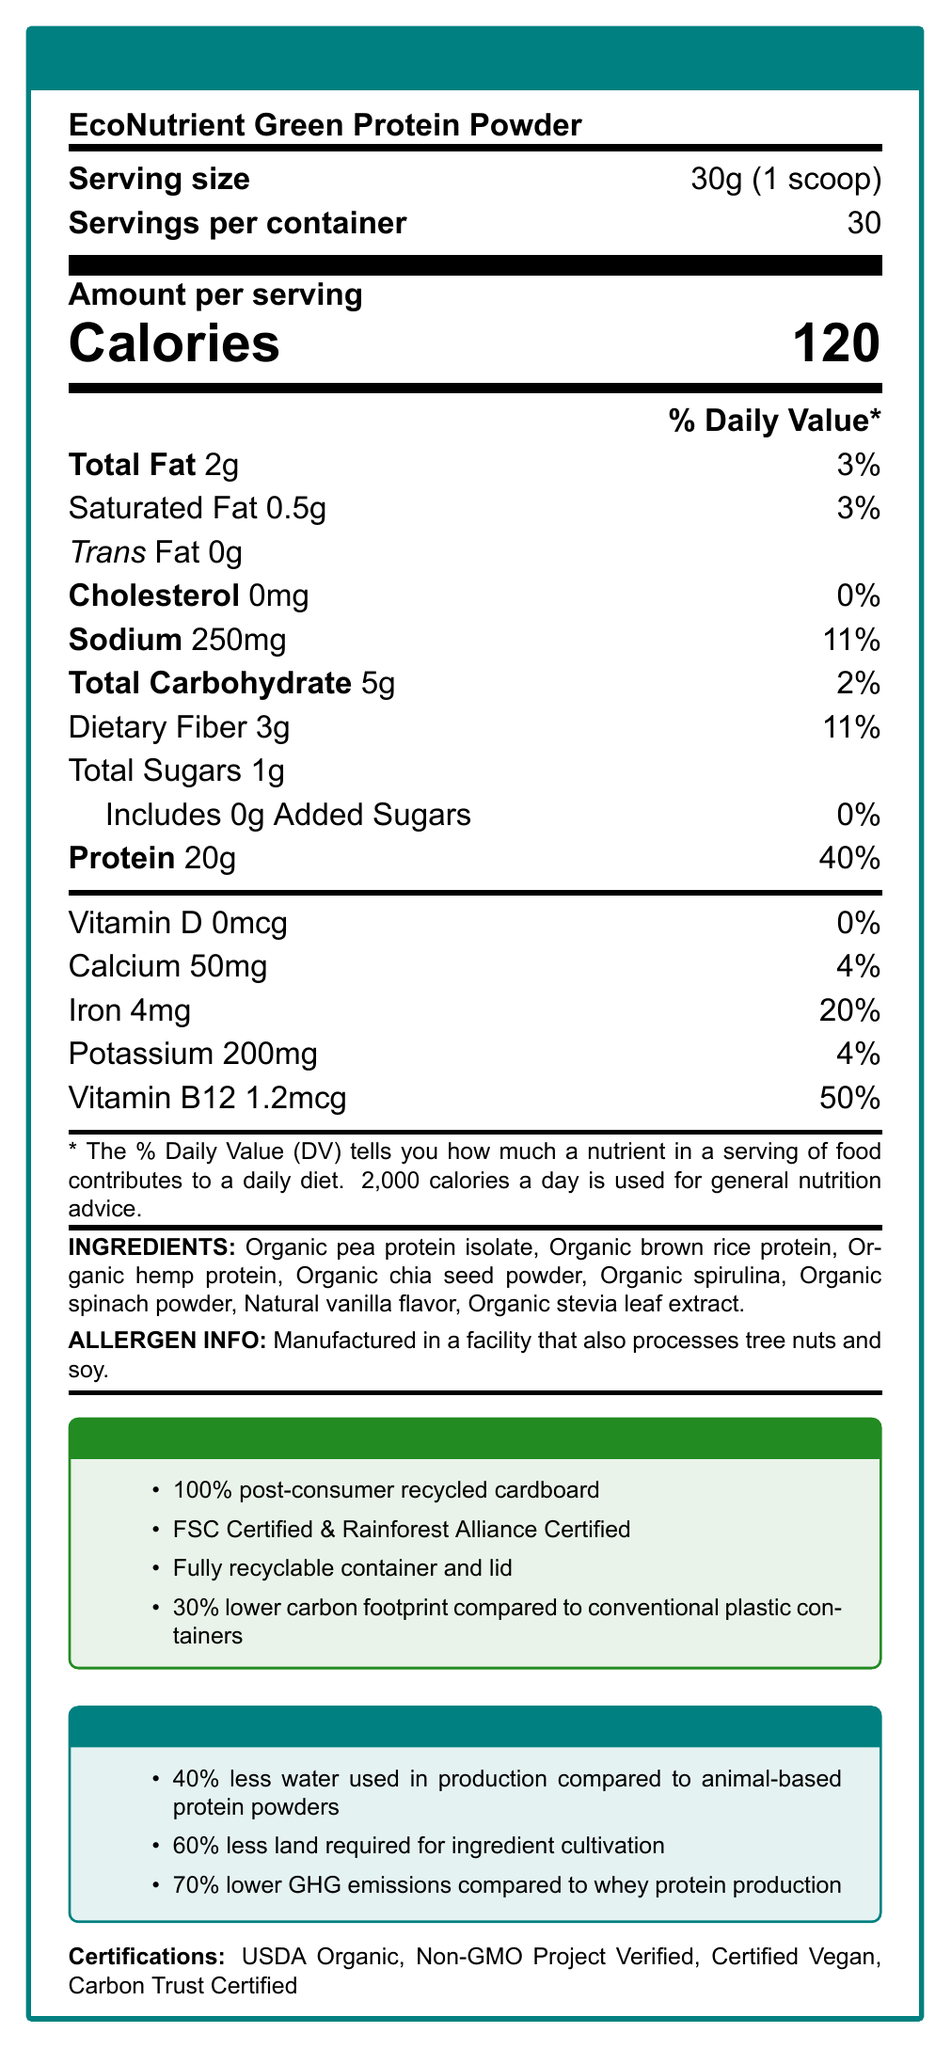what is the serving size? The document clearly states the serving size as 30g, which is equivalent to 1 scoop.
Answer: 30g (1 scoop) how many calories are there per serving? The document specifies that there are 120 calories per serving.
Answer: 120 what percentage of daily value for protein does one serving provide? According to the document, one serving of the protein powder provides 40% of the daily value for protein.
Answer: 40% are there any added sugars in this product? The document indicates that the product includes 0g of added sugars, contributing to 0% of the daily value.
Answer: No what are the main ingredients in this protein powder? The document lists these components as the main ingredients.
Answer: Organic pea protein isolate, Organic brown rice protein, Organic hemp protein, Organic chia seed powder, Organic spirulina, Organic spinach powder, Natural vanilla flavor, Organic stevia leaf extract which vitamins and minerals are included, and at what daily values? A. Vitamin D - 50%, Vitamin B12 - 20% B. Calcium - 4%, Iron - 20% C. Potassium - 50%, Iron - 4% D. Vitamin B12 - 50%, Potassium - 4% The document shows Vitamin B12 at 50% daily value and Potassium at 4% daily value.
Answer: D what material is used for the packaging of this product? A. Biodegradable plastic B. Recycled paper C. Recycled aluminum D. Post-consumer recycled cardboard The document states the packaging material is 100% post-consumer recycled cardboard.
Answer: D does the packaging have any certifications? The document mentions FSC Certified and Rainforest Alliance Certified for the packaging.
Answer: Yes is this product vegan? The document states that the product is vegan and cruelty-free.
Answer: Yes what is the total fat content per serving? The document indicates the total fat content per serving is 2g.
Answer: 2g how does the water usage for producing this product compare to animal-based protein powders? The environmental impact section of the document claims that the production of this product uses 40% less water than animal-based protein powders.
Answer: 40% less what certifications does this product have? The document lists these certifications under the certifications section.
Answer: USDA Organic, Non-GMO Project Verified, Certified Vegan, Carbon Trust Certified where is the pea protein sourced from? The document specifies that the pea protein in this product is sourced from Canada.
Answer: Canada summarize the main points of this nutrition facts label of the product. This summary includes the key points about the nutritional content, ingredient sourcing, eco-friendly packaging, certifications, and environmental impact of the product.
Answer: The nutrition facts label for EcoNutrient Green Protein Powder details its nutritional content per 30g serving, including 120 calories and 20g of protein. It is made from organic, non-GMO ingredients, and supports regenerative agriculture. The product uses eco-friendly packaging and has several certifications like USDA Organic and Certified Vegan. The packaging is fully recyclable, with a lower carbon footprint compared to conventional plastic containers. The production process for this product uses significantly less water, land, and emits fewer greenhouse gases compared to animal-based protein powders. what is the carbon footprint of this product's packaging compared to conventional plastic containers? The document indicates that the packaging has a 30% lower carbon footprint compared to conventional plastic containers.
Answer: 30% lower what is the total carbohydrate content per serving? According to the document, the total carbohydrate content per serving is 5g.
Answer: 5g is the total fiber content per serving higher than the total sugar content per serving? The total dietary fiber content is 3g, while the total sugar content is 1g, so the fiber content is higher.
Answer: Yes what is the source country for spirulina used in this product? The document specifies that the spirulina is sourced from Hawaii, USA.
Answer: Hawaii, USA can the exact price of the product be determined from this document? The document does not provide any details about the price of the product.
Answer: Not enough information 